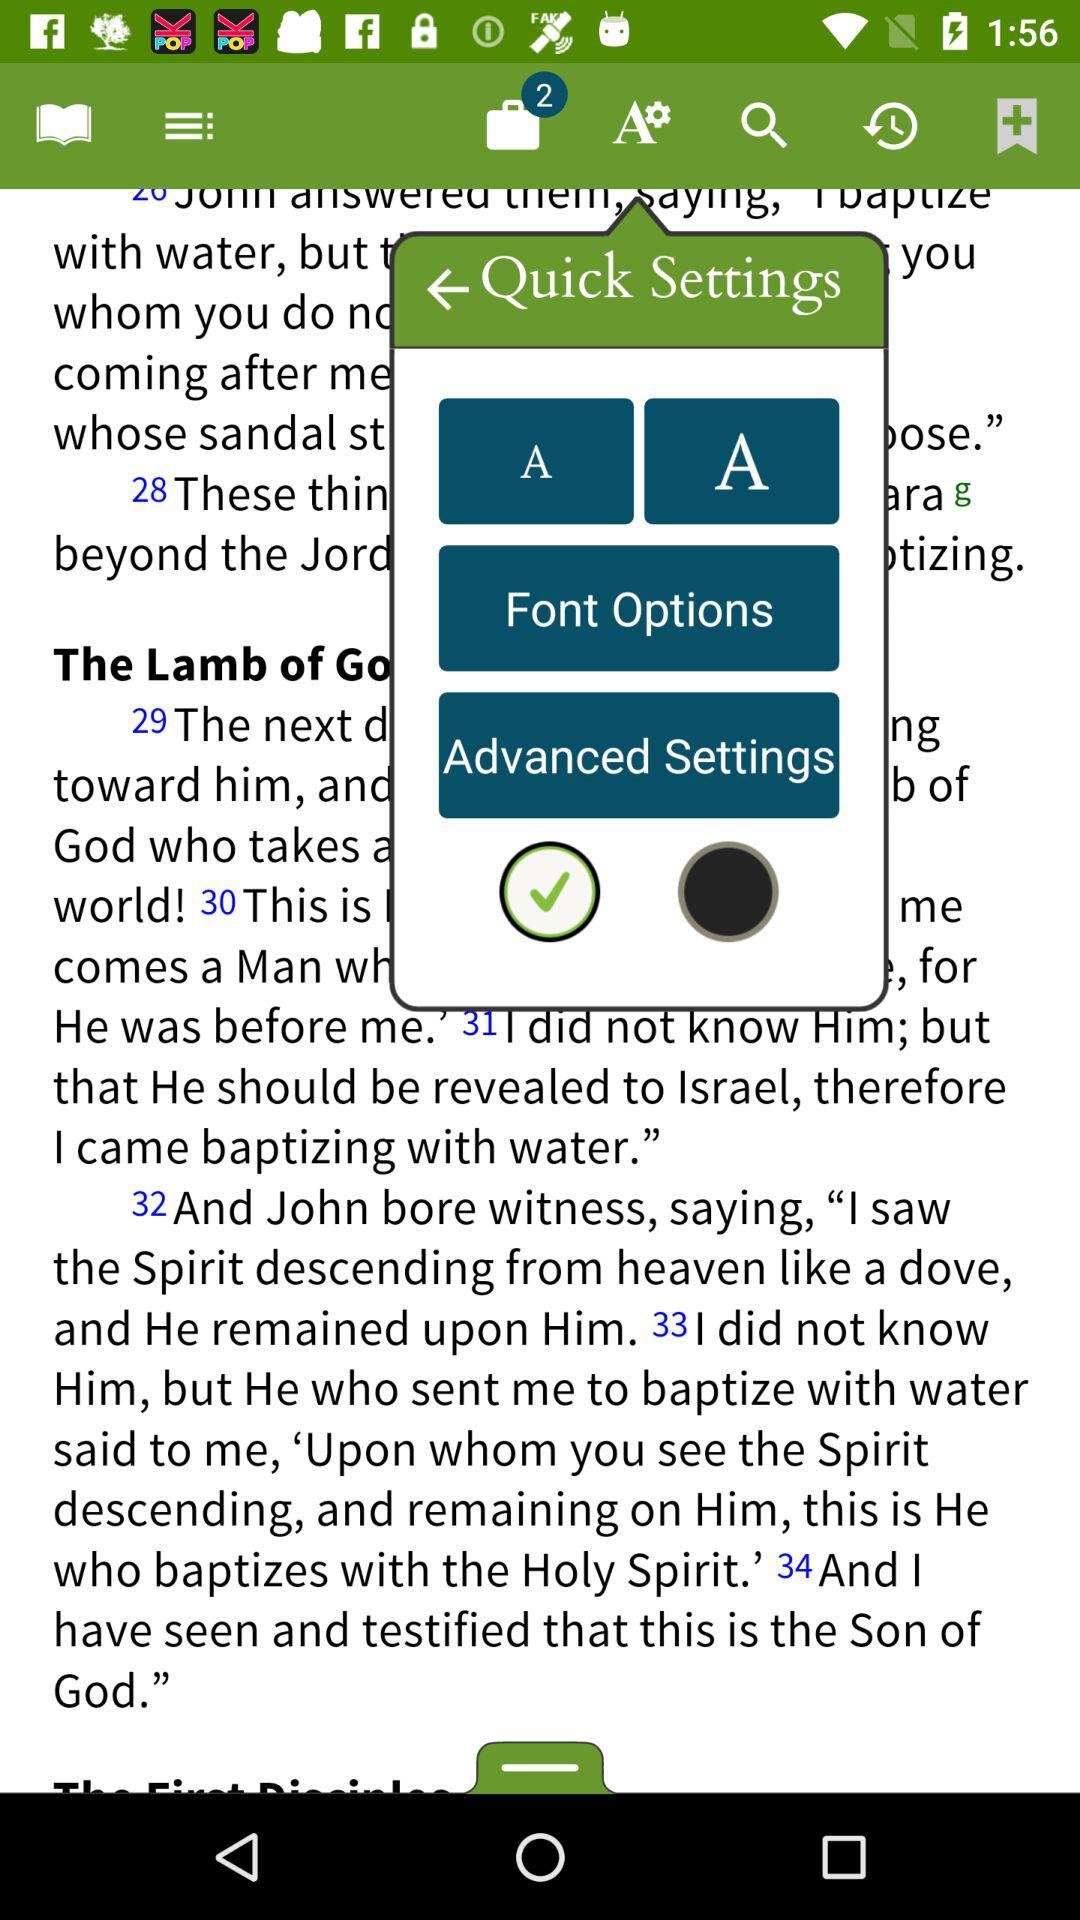How many notifications are received?
When the provided information is insufficient, respond with <no answer>. <no answer> 